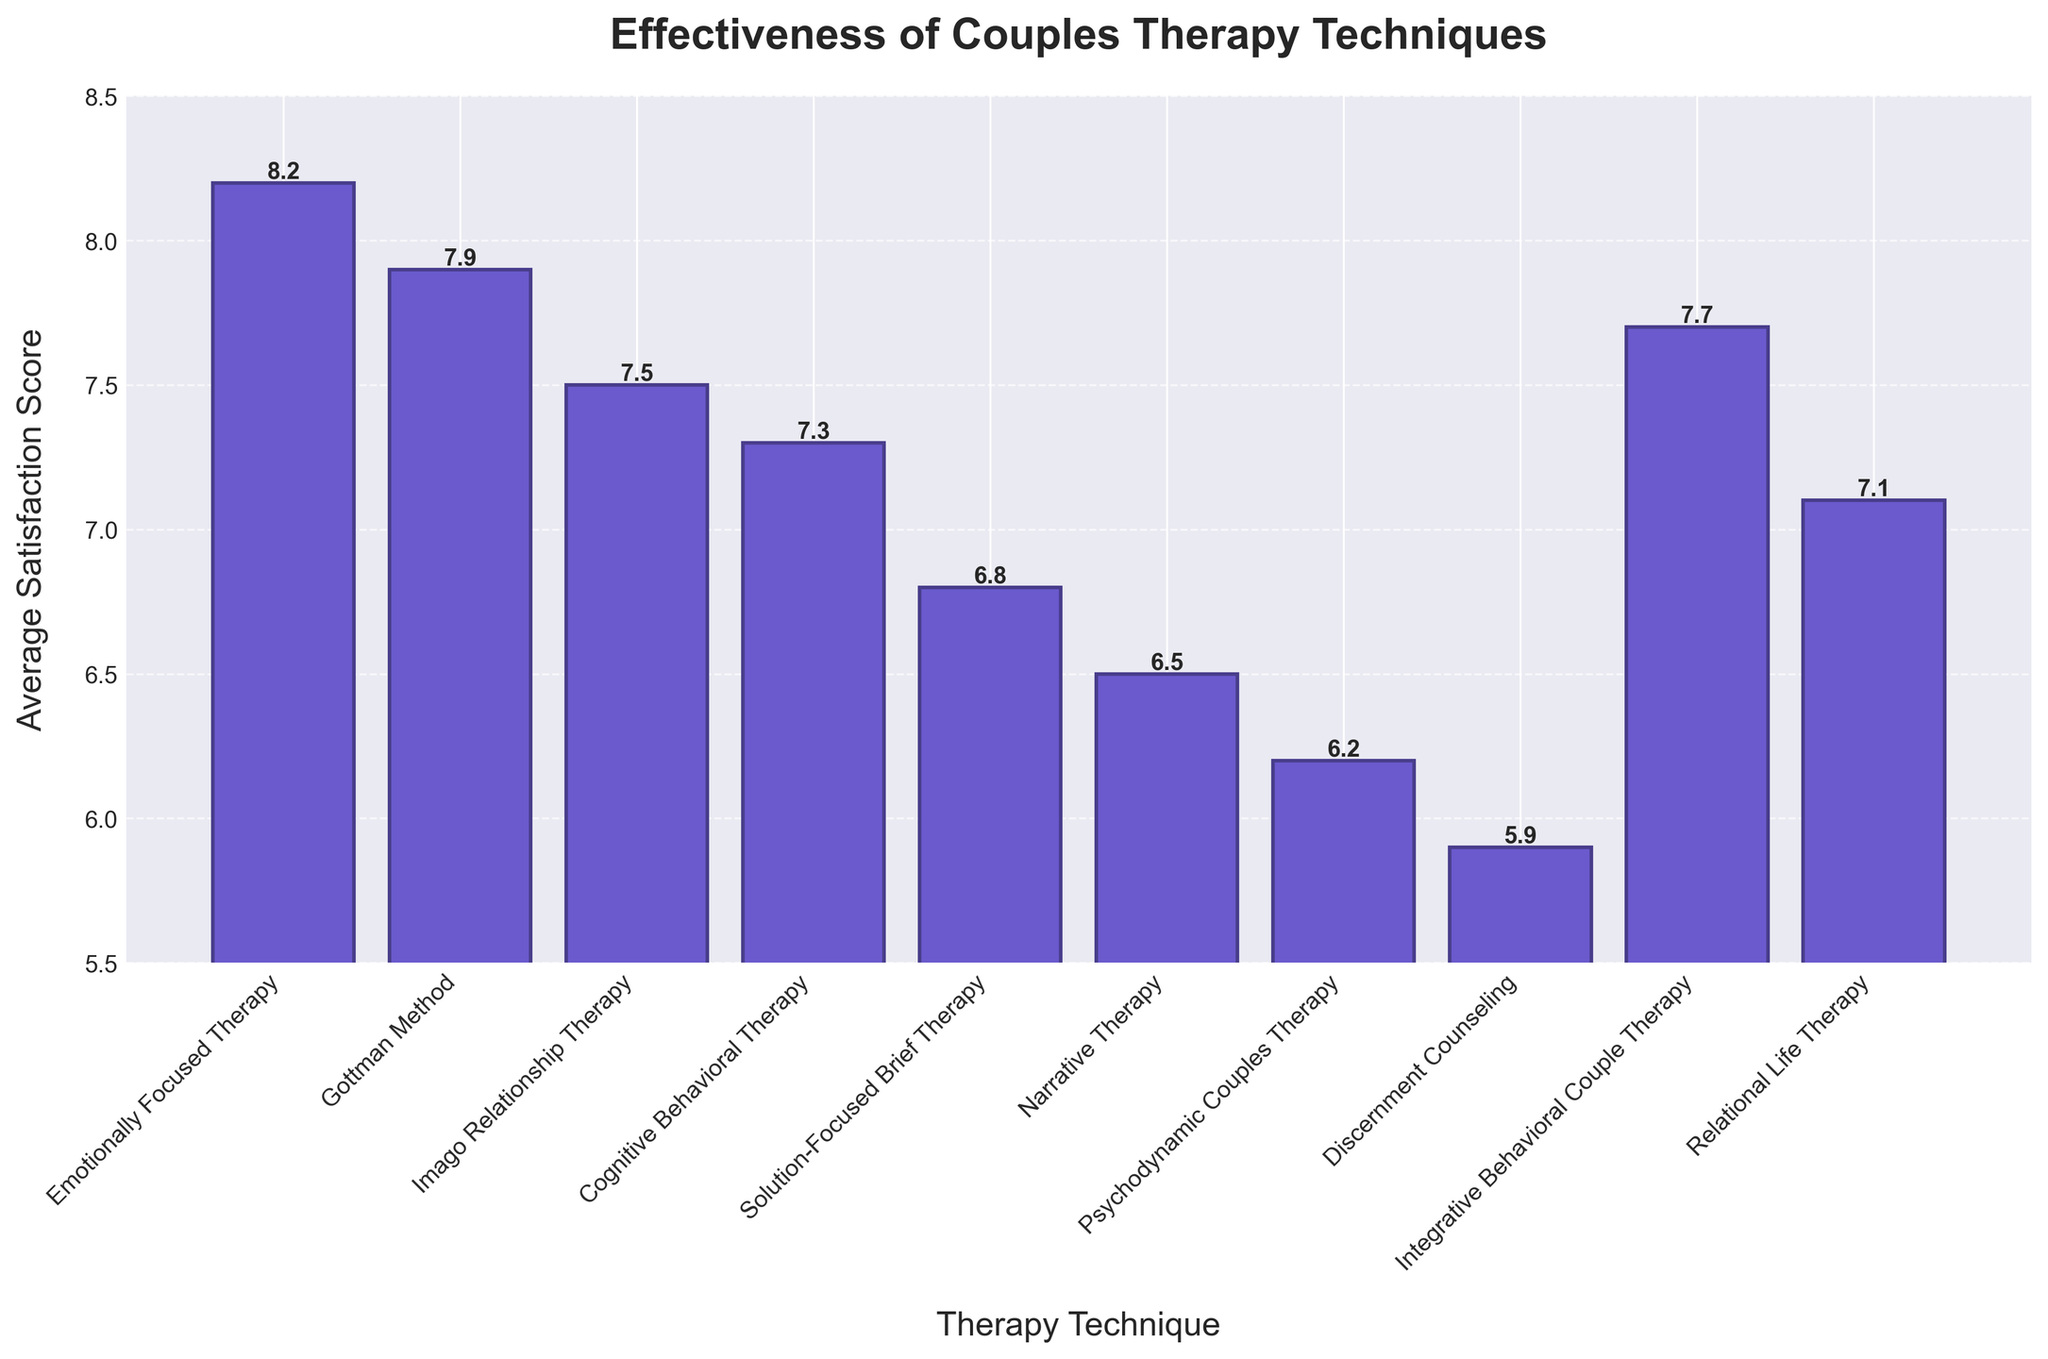What is the highest average satisfaction score among the therapy techniques? By looking at the height of the bars, the tallest bar represents Emotionally Focused Therapy with a score of 8.2, indicating it has the highest average satisfaction score.
Answer: 8.2 Which therapy technique has the lowest average satisfaction score? The shortest bar indicates the lowest average satisfaction score. That bar represents Discernment Counseling with an average score of 5.9.
Answer: 5.9 Compare the average satisfaction score between Gottman Method and Imago Relationship Therapy. Which one is higher and by how much? The bar representing Gottman Method shows a score of 7.9, while Imago Relationship Therapy has a score of 7.5. The difference between them is 7.9 - 7.5 = 0.4.
Answer: Gottman Method, by 0.4 What is the average of the lowest three satisfaction scores? The three lowest scores are Discernment Counseling (5.9), Psychodynamic Couples Therapy (6.2), and Narrative Therapy (6.5). Their average is (5.9 + 6.2 + 6.5) / 3 = 18.6 / 3 = 6.2.
Answer: 6.2 Compare the satisfaction scores of Cognitive Behavioral Therapy and Integrative Behavioral Couple Therapy. Which one has a higher score, and by how much? Cognitive Behavioral Therapy has a score of 7.3, and Integrative Behavioral Couple Therapy has a score of 7.7. The difference between them is 7.7 - 7.3 = 0.4.
Answer: Integrative Behavioral Couple Therapy, by 0.4 Which therapy techniques have scores greater than 7 but less than 8? By checking the range of scores, the techniques with scores greater than 7 and less than 8 are Gottman Method (7.9), Integrative Behavioral Couple Therapy (7.7), and Relational Life Therapy (7.1).
Answer: Gottman Method, Integrative Behavioral Couple Therapy, Relational Life Therapy What is the median satisfaction score of all therapy techniques? To find the median, list the satisfaction scores in ascending order: 5.9, 6.2, 6.5, 6.8, 7.1, 7.3, 7.5, 7.7, 7.9, 8.2. The middle value is the average of the 5th and 6th values: (7.1 + 7.3)/2 = 7.2.
Answer: 7.2 